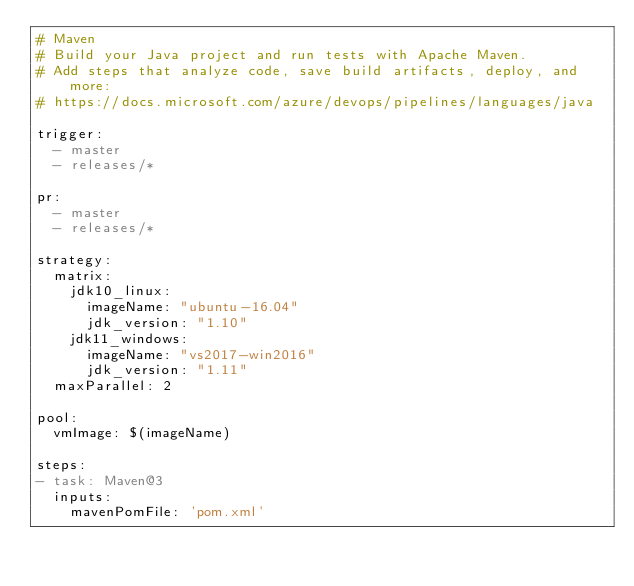Convert code to text. <code><loc_0><loc_0><loc_500><loc_500><_YAML_># Maven
# Build your Java project and run tests with Apache Maven.
# Add steps that analyze code, save build artifacts, deploy, and more:
# https://docs.microsoft.com/azure/devops/pipelines/languages/java

trigger:
  - master
  - releases/*

pr:
  - master
  - releases/*

strategy:
  matrix:
    jdk10_linux:
      imageName: "ubuntu-16.04"
      jdk_version: "1.10"
    jdk11_windows:
      imageName: "vs2017-win2016"
      jdk_version: "1.11"
  maxParallel: 2

pool:
  vmImage: $(imageName)

steps:
- task: Maven@3
  inputs:
    mavenPomFile: 'pom.xml'</code> 